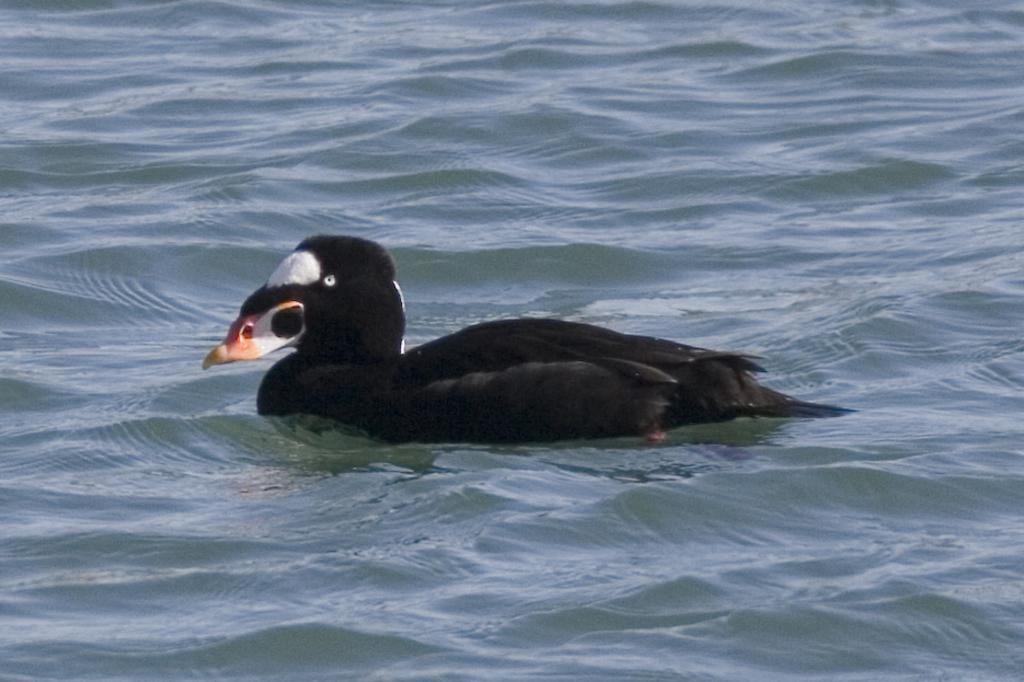What type of animal is in the image? There is a black duck in the image. Where is the black duck located? The black duck is on water. What type of sweater is the duck wearing in the image? There is no sweater present in the image; the duck is a black duck on water. 